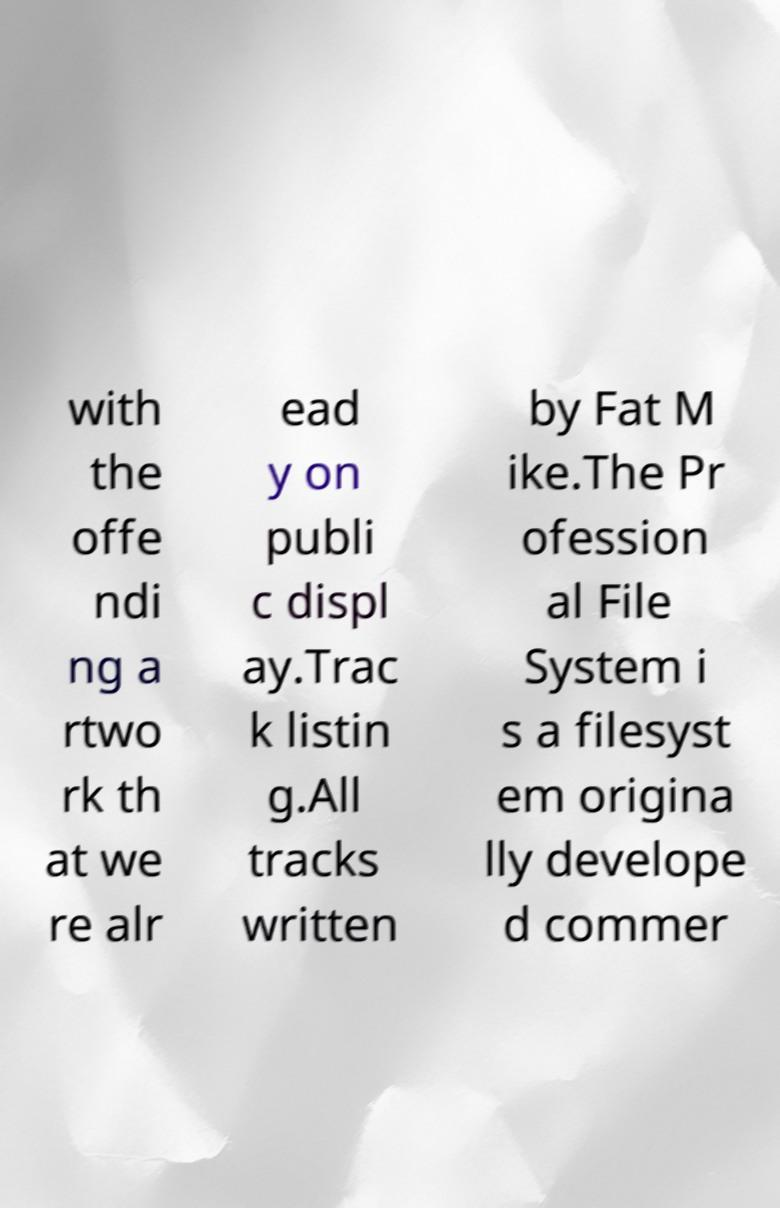What messages or text are displayed in this image? I need them in a readable, typed format. with the offe ndi ng a rtwo rk th at we re alr ead y on publi c displ ay.Trac k listin g.All tracks written by Fat M ike.The Pr ofession al File System i s a filesyst em origina lly develope d commer 